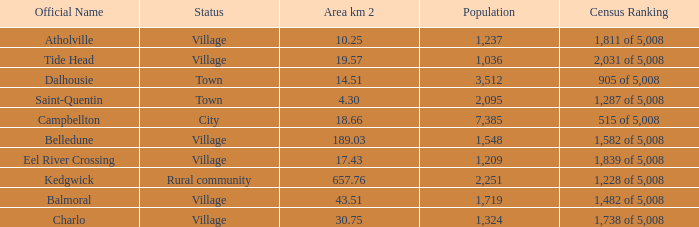When the communities name is Balmoral and the area is over 43.51 kilometers squared, what's the total population amount? 0.0. 